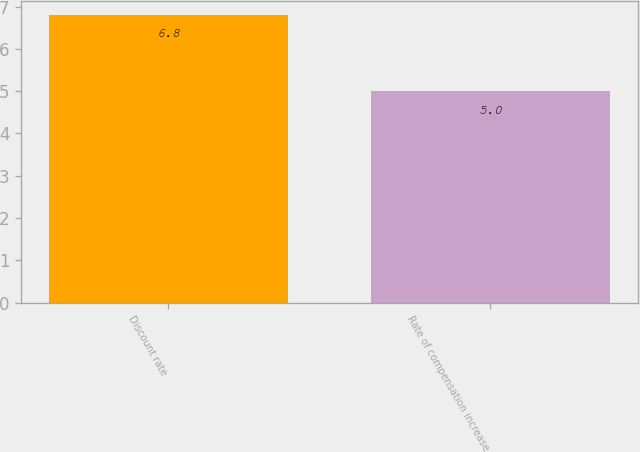Convert chart. <chart><loc_0><loc_0><loc_500><loc_500><bar_chart><fcel>Discount rate<fcel>Rate of compensation increase<nl><fcel>6.8<fcel>5<nl></chart> 